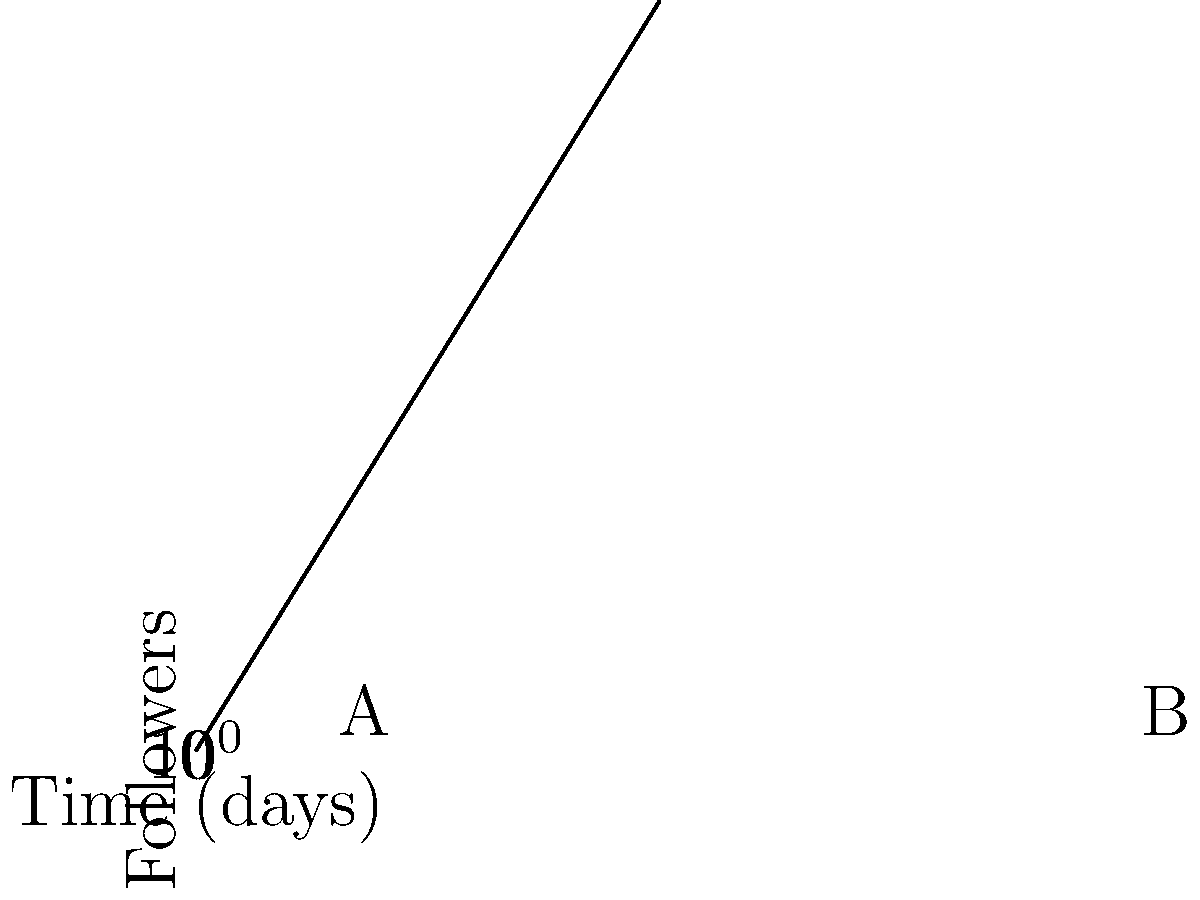As a journalist, you've published a viral news story about a local community's innovative solution to homelessness. The graph shows the exponential growth of your social media followers on a logarithmic scale over 10 days. If point A represents 1000 followers on day 2 and point B represents the number of followers on day 6, how many followers do you have on day 6? Let's approach this step-by-step:

1) The exponential growth function can be written as $f(t) = Ce^{kt}$, where $C$ is the initial number of followers, $k$ is the growth rate, and $t$ is time in days.

2) We know that at $t=2$ (point A), $f(2) = 1000$. Let's use this to find $C$:

   $1000 = Ce^{2k}$

3) The graph is on a logarithmic scale, so the vertical distance between points A and B represents the ratio of followers at these points. This ratio is $e^{2k}$ because the horizontal distance is 4 days (from day 2 to day 6).

4) On a log scale, equal vertical distances represent equal ratios. The vertical distance from the x-axis to point A is the same as the distance from A to B. This means:

   $\frac{f(6)}{f(2)} = \frac{f(2)}{f(0)} = e^{2k} = \frac{1000}{C}$

5) Therefore, $f(6) = 1000 \cdot \frac{1000}{C} = \frac{10^6}{C}$

6) To find $C$, we can use the equation from step 2:

   $C = \frac{1000}{e^{2k}} = \frac{1000}{\frac{1000}{C}} = C^2 \cdot 10^{-3}$

   Solving this: $C = 10^{\frac{3}{2}} = \sqrt{1000} \approx 31.6228$

7) Now we can calculate $f(6)$:

   $f(6) = \frac{10^6}{C} = \frac{10^6}{31.6228} \approx 31,622.8$
Answer: 31,623 followers (rounded to nearest whole number) 